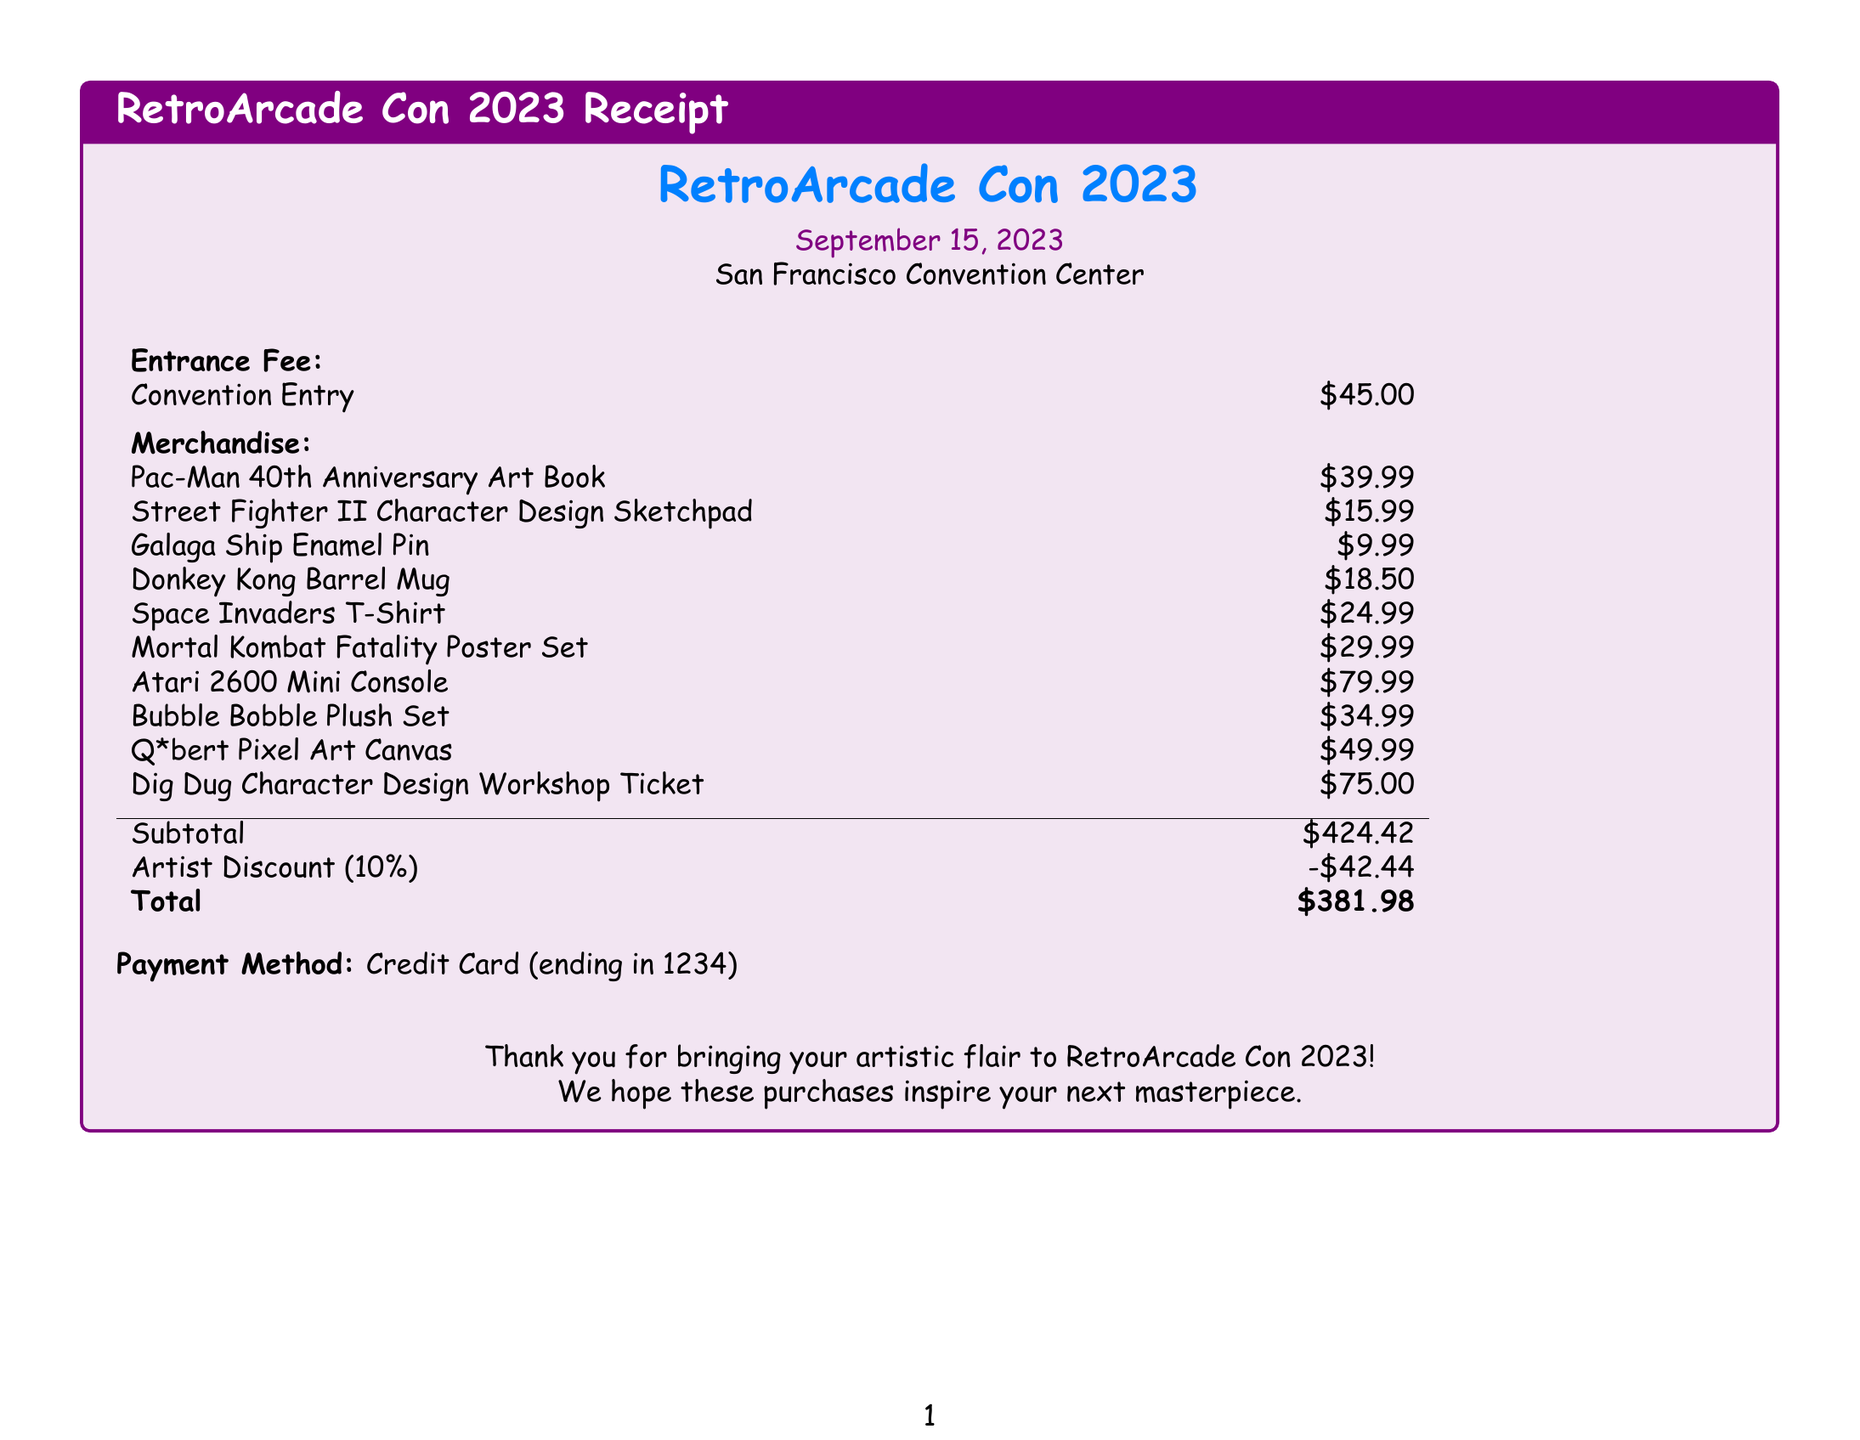what is the name of the convention? The name of the convention is presented at the top of the document.
Answer: RetroArcade Con 2023 what is the entrance fee? The entrance fee is listed under the Entrance Fee section of the document.
Answer: $45.00 what was the date of the convention? The date is mentioned just below the convention name in the document.
Answer: September 15, 2023 how many merchandise items were purchased? To find this, count the number of items listed in the Merchandise section.
Answer: 10 what is the total before discount? The total before discount is located in the table towards the end of the document.
Answer: $424.42 what percentage is the artist discount? The artist discount is explicitly stated in the document.
Answer: 10% which item had the highest price? The item with the highest price can be identified by reviewing the prices listed under Merchandise.
Answer: Atari 2600 Mini Console what payment method was used? The payment method is indicated towards the end of the document.
Answer: Credit Card what is the total amount after the discount? The final total after discount is clearly listed in the document.
Answer: $381.98 what is included in the merchandise list? The merchandise list includes several items, as detailed under Merchandise.
Answer: Various arcade game-related items 